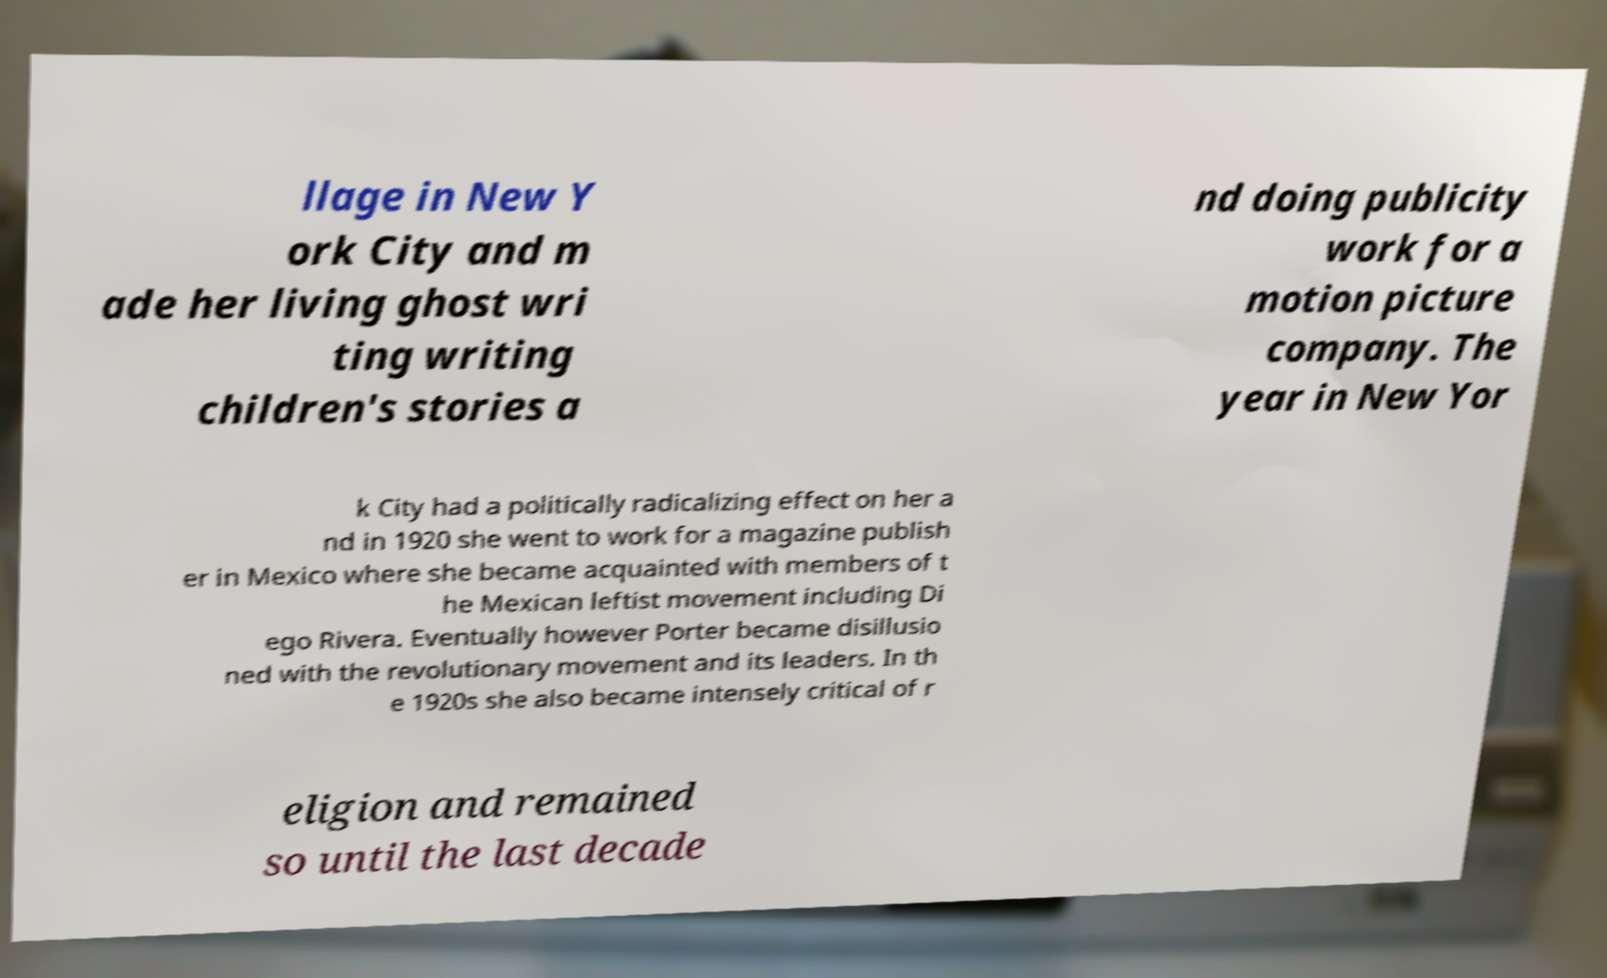I need the written content from this picture converted into text. Can you do that? llage in New Y ork City and m ade her living ghost wri ting writing children's stories a nd doing publicity work for a motion picture company. The year in New Yor k City had a politically radicalizing effect on her a nd in 1920 she went to work for a magazine publish er in Mexico where she became acquainted with members of t he Mexican leftist movement including Di ego Rivera. Eventually however Porter became disillusio ned with the revolutionary movement and its leaders. In th e 1920s she also became intensely critical of r eligion and remained so until the last decade 